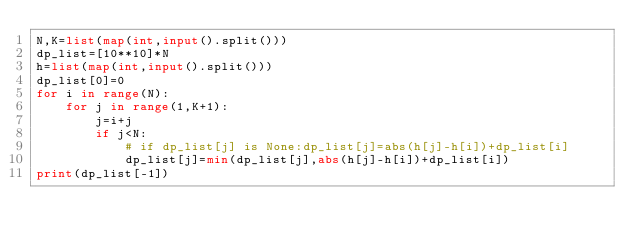<code> <loc_0><loc_0><loc_500><loc_500><_Python_>N,K=list(map(int,input().split()))
dp_list=[10**10]*N
h=list(map(int,input().split()))
dp_list[0]=0
for i in range(N):
    for j in range(1,K+1):
        j=i+j
        if j<N:
            # if dp_list[j] is None:dp_list[j]=abs(h[j]-h[i])+dp_list[i]
            dp_list[j]=min(dp_list[j],abs(h[j]-h[i])+dp_list[i])
print(dp_list[-1])

</code> 